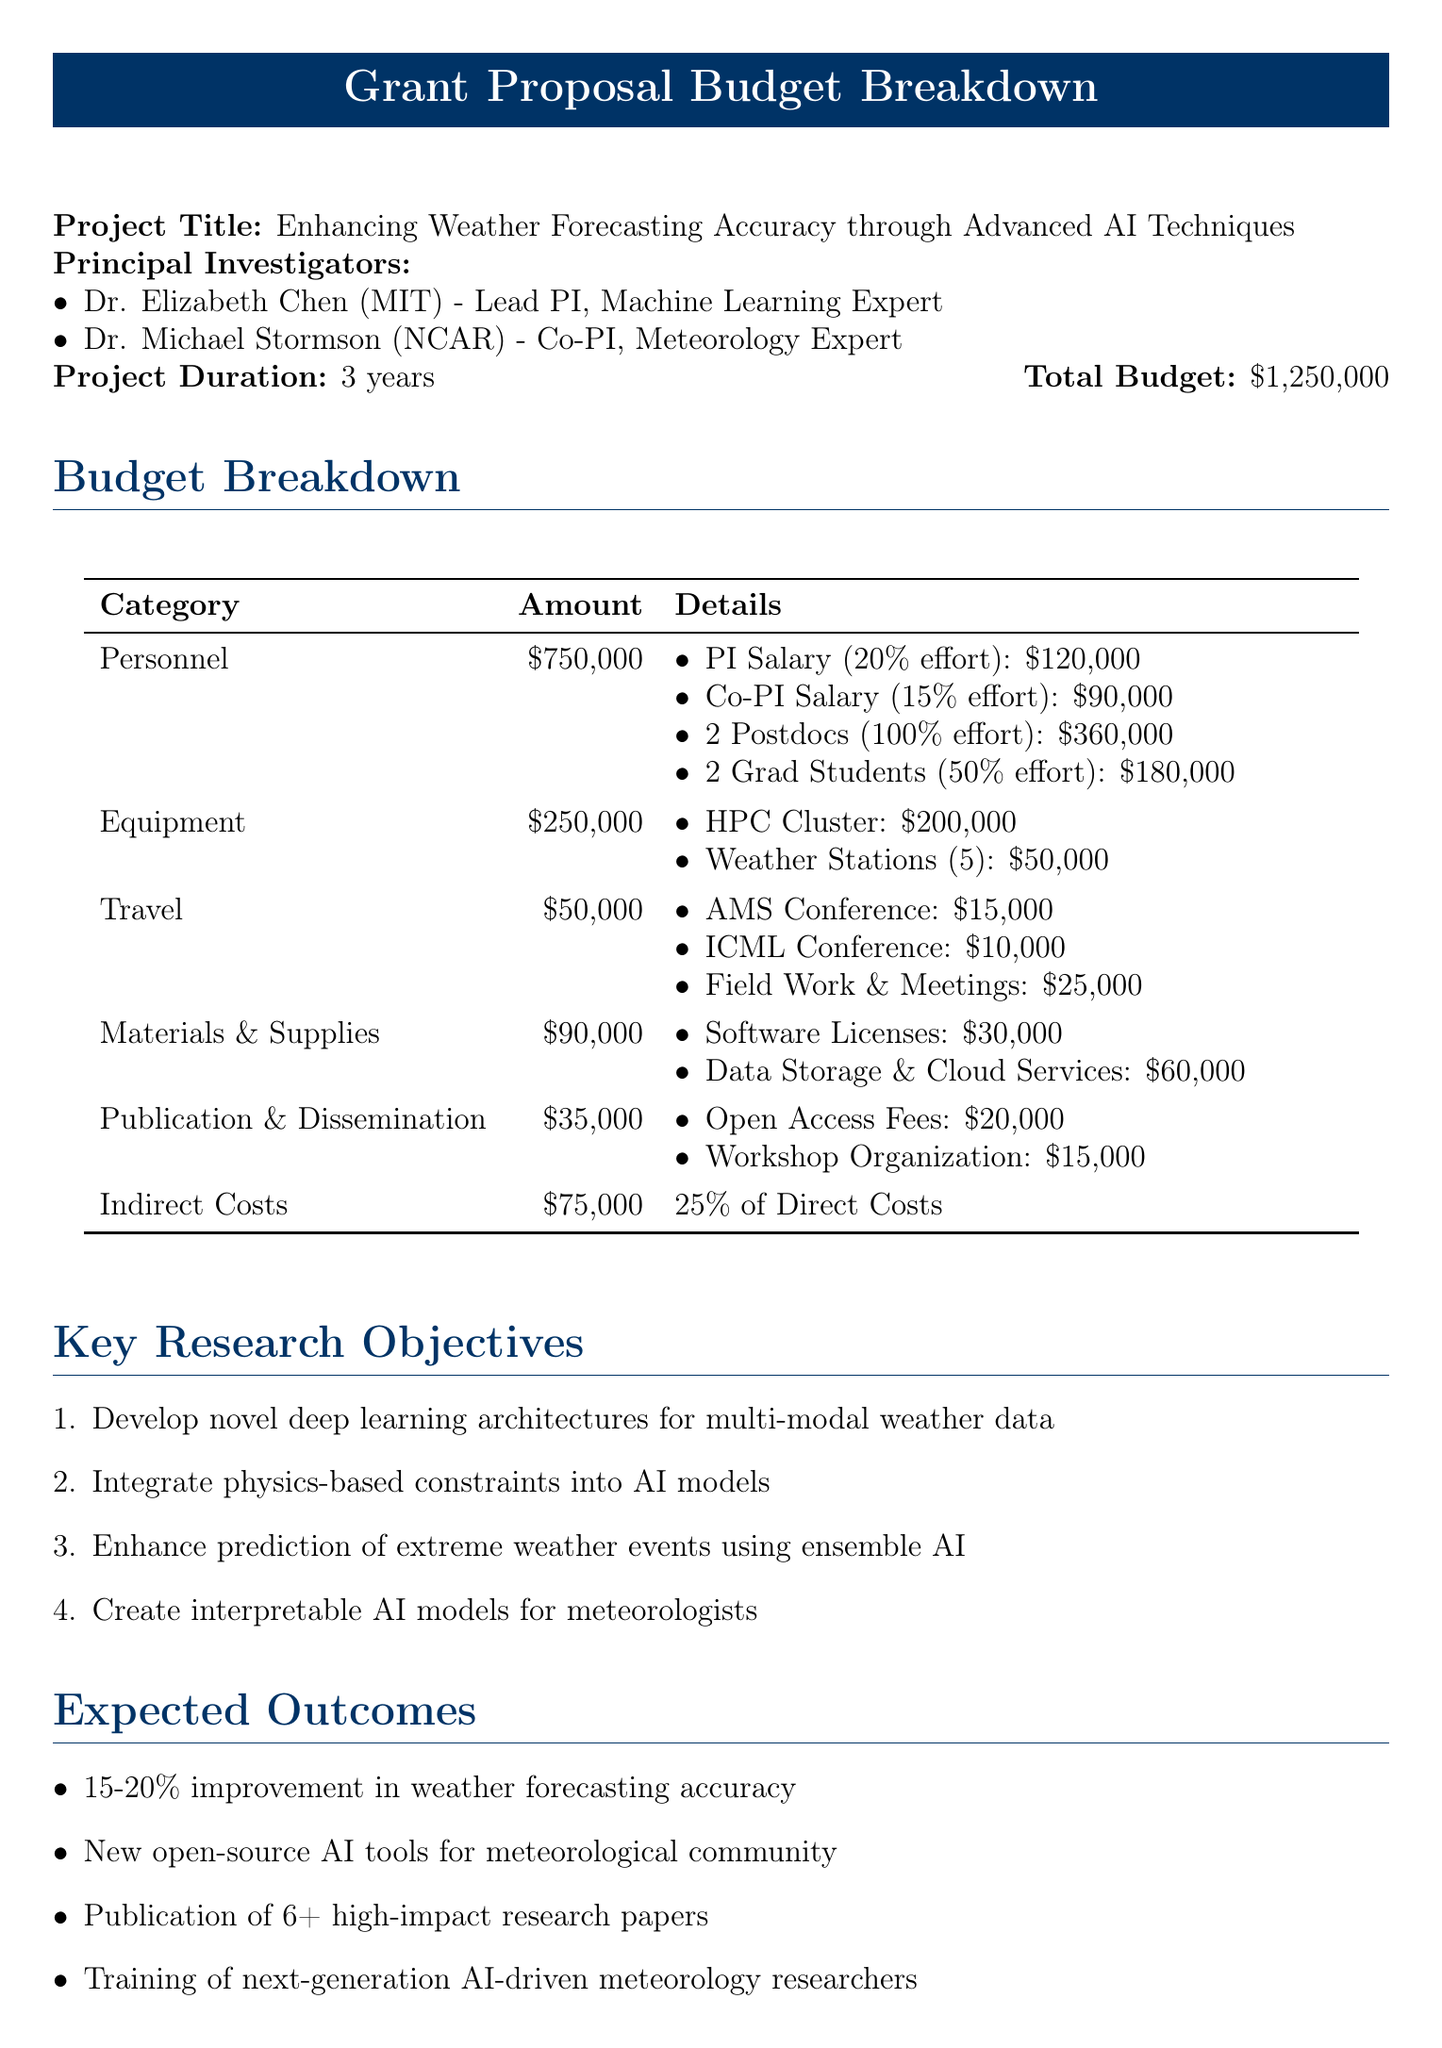What is the project title? The project title is stated at the beginning of the document.
Answer: Enhancing Weather Forecasting Accuracy through Advanced AI Techniques Who is the Lead Principal Investigator? The Lead Principal Investigator is listed in the section about principal investigators.
Answer: Dr. Elizabeth Chen What is the total budget for the project? The total budget is mentioned in the heading of the document.
Answer: $1,250,000 What is the duration of the project? The project duration is explicitly stated in the document.
Answer: 3 years What is the subtotal for Personnel costs? The subtotal for Personnel costs is provided in the budget breakdown section.
Answer: $750,000 How many Graduate Students are included in the budget? The number of Graduate Students is listed under the Personnel category in the document.
Answer: 2 What percentage of the direct costs does the Indirect Costs category represent? This information can be found in the budget breakdown for indirect costs.
Answer: 25% Name one expected outcome of the project. Expected outcomes are listed in the respective section of the document.
Answer: Improved short-term and long-term weather forecasting accuracy by 15-20% Which institution is a co-collaborating entity in this project? The collaborating institutions are listed under a specific section in the document.
Answer: National Center for Atmospheric Research What is one ethical consideration mentioned in the document? Ethical considerations are explicitly outlined in the corresponding section of the document.
Answer: Ensuring AI model fairness across different geographical regions 